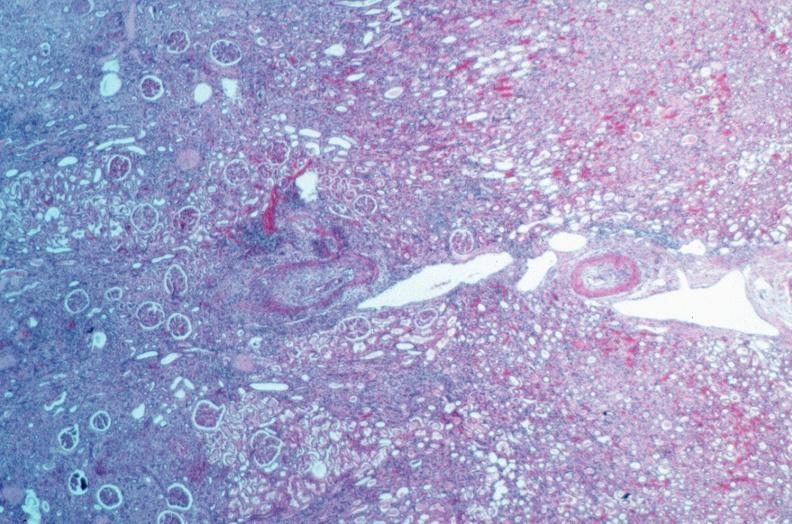what is present?
Answer the question using a single word or phrase. Vasculature 